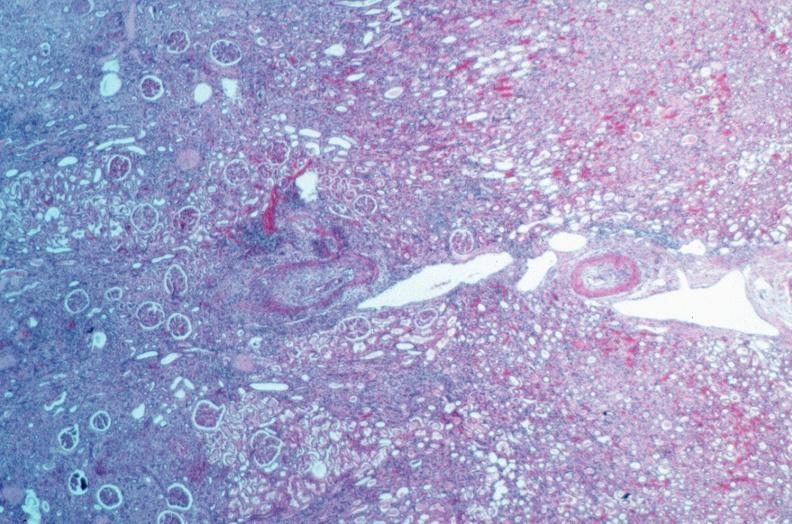what is present?
Answer the question using a single word or phrase. Vasculature 